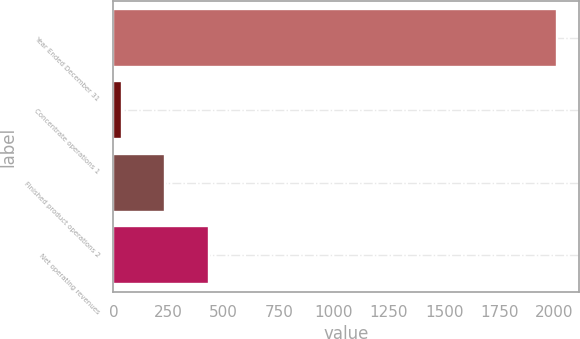<chart> <loc_0><loc_0><loc_500><loc_500><bar_chart><fcel>Year Ended December 31<fcel>Concentrate operations 1<fcel>Finished product operations 2<fcel>Net operating revenues<nl><fcel>2012<fcel>38<fcel>235.4<fcel>432.8<nl></chart> 